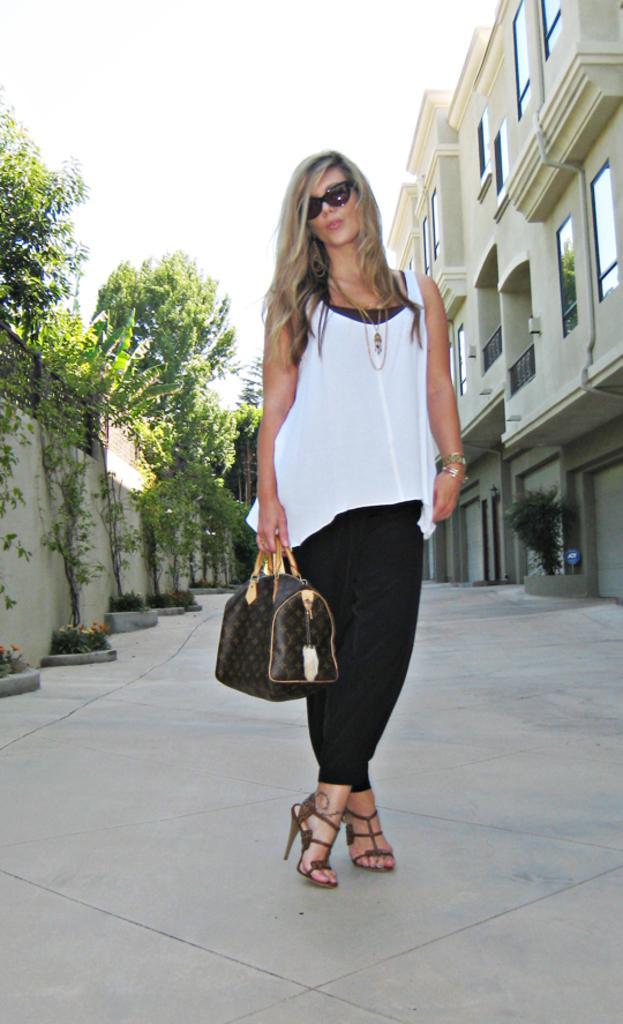Could you give a brief overview of what you see in this image? In this image there is the sky towards the top of the image, there is a building towards the right of the image, there are windows, there are plants towards the left of the image, there is a wall towards the left of the image, there is ground towards the bottom of the image, there is a woman standing, she is holding an object, she is wearing goggles. 